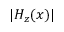<formula> <loc_0><loc_0><loc_500><loc_500>| H _ { z } ( x ) |</formula> 